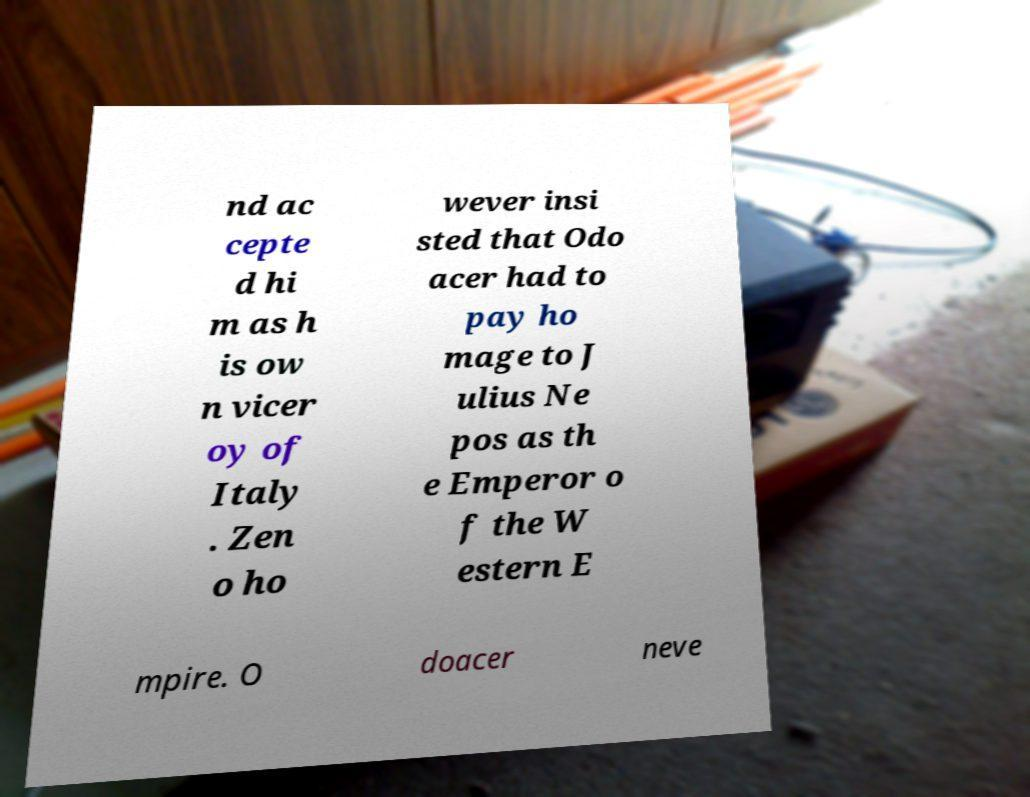Could you assist in decoding the text presented in this image and type it out clearly? nd ac cepte d hi m as h is ow n vicer oy of Italy . Zen o ho wever insi sted that Odo acer had to pay ho mage to J ulius Ne pos as th e Emperor o f the W estern E mpire. O doacer neve 